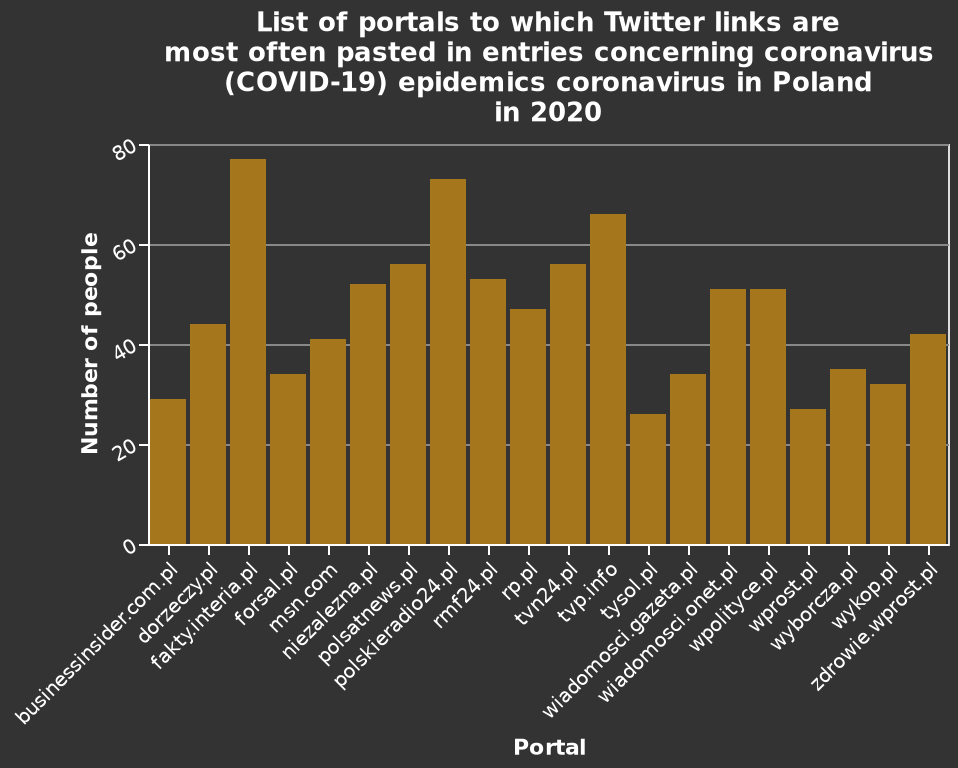<image>
What does the bar plot show?  The bar plot shows the frequency of Twitter links being pasted in entries related to the coronavirus (COVID-19) epidemic in Poland in 2020, categorized by different portals. Did Epps Rixey win more games than Pete Donahue? Yes Which website has the lowest number of people according to the figure? The figure does not provide information about the lowest number of people. 